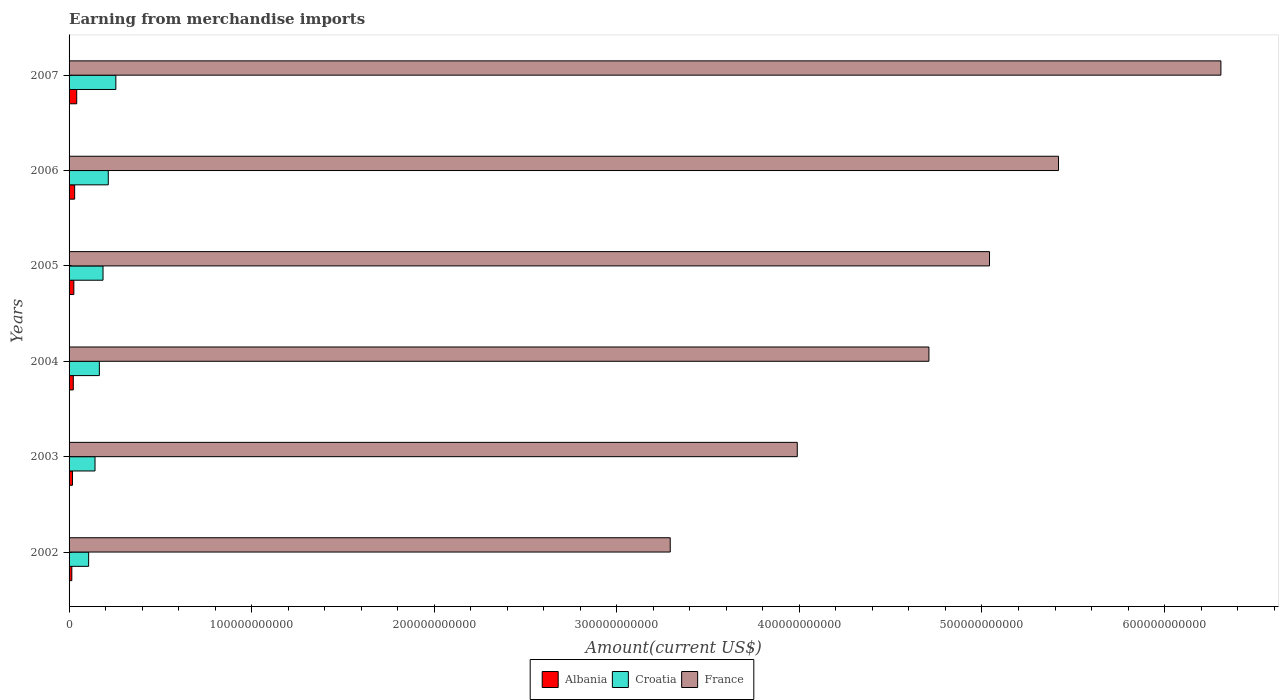How many different coloured bars are there?
Ensure brevity in your answer.  3. In how many cases, is the number of bars for a given year not equal to the number of legend labels?
Make the answer very short. 0. What is the amount earned from merchandise imports in Croatia in 2002?
Provide a short and direct response. 1.07e+1. Across all years, what is the maximum amount earned from merchandise imports in Albania?
Keep it short and to the point. 4.19e+09. Across all years, what is the minimum amount earned from merchandise imports in Croatia?
Offer a terse response. 1.07e+1. In which year was the amount earned from merchandise imports in Albania maximum?
Your response must be concise. 2007. In which year was the amount earned from merchandise imports in France minimum?
Provide a short and direct response. 2002. What is the total amount earned from merchandise imports in France in the graph?
Offer a very short reply. 2.88e+12. What is the difference between the amount earned from merchandise imports in France in 2004 and that in 2007?
Make the answer very short. -1.60e+11. What is the difference between the amount earned from merchandise imports in Croatia in 2007 and the amount earned from merchandise imports in Albania in 2003?
Make the answer very short. 2.38e+1. What is the average amount earned from merchandise imports in Albania per year?
Your answer should be compact. 2.59e+09. In the year 2005, what is the difference between the amount earned from merchandise imports in Croatia and amount earned from merchandise imports in Albania?
Keep it short and to the point. 1.60e+1. What is the ratio of the amount earned from merchandise imports in Albania in 2003 to that in 2004?
Your answer should be very brief. 0.81. Is the difference between the amount earned from merchandise imports in Croatia in 2003 and 2007 greater than the difference between the amount earned from merchandise imports in Albania in 2003 and 2007?
Your answer should be very brief. No. What is the difference between the highest and the second highest amount earned from merchandise imports in Croatia?
Your answer should be compact. 4.14e+09. What is the difference between the highest and the lowest amount earned from merchandise imports in France?
Give a very brief answer. 3.02e+11. In how many years, is the amount earned from merchandise imports in Albania greater than the average amount earned from merchandise imports in Albania taken over all years?
Provide a succinct answer. 3. Is the sum of the amount earned from merchandise imports in France in 2006 and 2007 greater than the maximum amount earned from merchandise imports in Croatia across all years?
Ensure brevity in your answer.  Yes. What does the 2nd bar from the top in 2006 represents?
Make the answer very short. Croatia. What does the 2nd bar from the bottom in 2007 represents?
Your answer should be compact. Croatia. Is it the case that in every year, the sum of the amount earned from merchandise imports in Albania and amount earned from merchandise imports in France is greater than the amount earned from merchandise imports in Croatia?
Keep it short and to the point. Yes. How many bars are there?
Offer a very short reply. 18. How many years are there in the graph?
Provide a short and direct response. 6. What is the difference between two consecutive major ticks on the X-axis?
Provide a succinct answer. 1.00e+11. Are the values on the major ticks of X-axis written in scientific E-notation?
Ensure brevity in your answer.  No. Does the graph contain grids?
Provide a short and direct response. No. Where does the legend appear in the graph?
Keep it short and to the point. Bottom center. How many legend labels are there?
Ensure brevity in your answer.  3. How are the legend labels stacked?
Provide a short and direct response. Horizontal. What is the title of the graph?
Make the answer very short. Earning from merchandise imports. What is the label or title of the X-axis?
Provide a short and direct response. Amount(current US$). What is the Amount(current US$) of Albania in 2002?
Ensure brevity in your answer.  1.50e+09. What is the Amount(current US$) of Croatia in 2002?
Give a very brief answer. 1.07e+1. What is the Amount(current US$) in France in 2002?
Make the answer very short. 3.29e+11. What is the Amount(current US$) of Albania in 2003?
Make the answer very short. 1.86e+09. What is the Amount(current US$) of Croatia in 2003?
Your answer should be very brief. 1.42e+1. What is the Amount(current US$) in France in 2003?
Provide a succinct answer. 3.99e+11. What is the Amount(current US$) in Albania in 2004?
Offer a very short reply. 2.31e+09. What is the Amount(current US$) of Croatia in 2004?
Your answer should be compact. 1.66e+1. What is the Amount(current US$) of France in 2004?
Keep it short and to the point. 4.71e+11. What is the Amount(current US$) of Albania in 2005?
Ensure brevity in your answer.  2.62e+09. What is the Amount(current US$) of Croatia in 2005?
Your response must be concise. 1.86e+1. What is the Amount(current US$) in France in 2005?
Offer a very short reply. 5.04e+11. What is the Amount(current US$) in Albania in 2006?
Offer a very short reply. 3.06e+09. What is the Amount(current US$) in Croatia in 2006?
Your response must be concise. 2.15e+1. What is the Amount(current US$) of France in 2006?
Ensure brevity in your answer.  5.42e+11. What is the Amount(current US$) in Albania in 2007?
Your answer should be very brief. 4.19e+09. What is the Amount(current US$) of Croatia in 2007?
Ensure brevity in your answer.  2.56e+1. What is the Amount(current US$) in France in 2007?
Your answer should be very brief. 6.31e+11. Across all years, what is the maximum Amount(current US$) in Albania?
Keep it short and to the point. 4.19e+09. Across all years, what is the maximum Amount(current US$) in Croatia?
Provide a succinct answer. 2.56e+1. Across all years, what is the maximum Amount(current US$) of France?
Your answer should be very brief. 6.31e+11. Across all years, what is the minimum Amount(current US$) in Albania?
Make the answer very short. 1.50e+09. Across all years, what is the minimum Amount(current US$) in Croatia?
Give a very brief answer. 1.07e+1. Across all years, what is the minimum Amount(current US$) of France?
Keep it short and to the point. 3.29e+11. What is the total Amount(current US$) of Albania in the graph?
Your answer should be compact. 1.55e+1. What is the total Amount(current US$) in Croatia in the graph?
Ensure brevity in your answer.  1.07e+11. What is the total Amount(current US$) in France in the graph?
Make the answer very short. 2.88e+12. What is the difference between the Amount(current US$) of Albania in 2002 and that in 2003?
Offer a terse response. -3.60e+08. What is the difference between the Amount(current US$) of Croatia in 2002 and that in 2003?
Your response must be concise. -3.49e+09. What is the difference between the Amount(current US$) in France in 2002 and that in 2003?
Provide a short and direct response. -6.96e+1. What is the difference between the Amount(current US$) in Albania in 2002 and that in 2004?
Make the answer very short. -8.05e+08. What is the difference between the Amount(current US$) in Croatia in 2002 and that in 2004?
Ensure brevity in your answer.  -5.87e+09. What is the difference between the Amount(current US$) of France in 2002 and that in 2004?
Your answer should be compact. -1.42e+11. What is the difference between the Amount(current US$) in Albania in 2002 and that in 2005?
Your answer should be compact. -1.11e+09. What is the difference between the Amount(current US$) in Croatia in 2002 and that in 2005?
Offer a terse response. -7.88e+09. What is the difference between the Amount(current US$) in France in 2002 and that in 2005?
Offer a terse response. -1.75e+11. What is the difference between the Amount(current US$) of Albania in 2002 and that in 2006?
Your response must be concise. -1.55e+09. What is the difference between the Amount(current US$) in Croatia in 2002 and that in 2006?
Ensure brevity in your answer.  -1.08e+1. What is the difference between the Amount(current US$) of France in 2002 and that in 2006?
Make the answer very short. -2.13e+11. What is the difference between the Amount(current US$) in Albania in 2002 and that in 2007?
Give a very brief answer. -2.68e+09. What is the difference between the Amount(current US$) of Croatia in 2002 and that in 2007?
Give a very brief answer. -1.49e+1. What is the difference between the Amount(current US$) of France in 2002 and that in 2007?
Offer a terse response. -3.02e+11. What is the difference between the Amount(current US$) in Albania in 2003 and that in 2004?
Ensure brevity in your answer.  -4.45e+08. What is the difference between the Amount(current US$) of Croatia in 2003 and that in 2004?
Keep it short and to the point. -2.38e+09. What is the difference between the Amount(current US$) in France in 2003 and that in 2004?
Offer a terse response. -7.21e+1. What is the difference between the Amount(current US$) in Albania in 2003 and that in 2005?
Your response must be concise. -7.54e+08. What is the difference between the Amount(current US$) in Croatia in 2003 and that in 2005?
Make the answer very short. -4.39e+09. What is the difference between the Amount(current US$) in France in 2003 and that in 2005?
Your answer should be very brief. -1.05e+11. What is the difference between the Amount(current US$) in Albania in 2003 and that in 2006?
Your answer should be very brief. -1.19e+09. What is the difference between the Amount(current US$) of Croatia in 2003 and that in 2006?
Make the answer very short. -7.27e+09. What is the difference between the Amount(current US$) of France in 2003 and that in 2006?
Offer a terse response. -1.43e+11. What is the difference between the Amount(current US$) of Albania in 2003 and that in 2007?
Keep it short and to the point. -2.32e+09. What is the difference between the Amount(current US$) in Croatia in 2003 and that in 2007?
Keep it short and to the point. -1.14e+1. What is the difference between the Amount(current US$) of France in 2003 and that in 2007?
Offer a terse response. -2.32e+11. What is the difference between the Amount(current US$) of Albania in 2004 and that in 2005?
Your answer should be very brief. -3.09e+08. What is the difference between the Amount(current US$) in Croatia in 2004 and that in 2005?
Ensure brevity in your answer.  -2.01e+09. What is the difference between the Amount(current US$) of France in 2004 and that in 2005?
Give a very brief answer. -3.32e+1. What is the difference between the Amount(current US$) in Albania in 2004 and that in 2006?
Provide a succinct answer. -7.49e+08. What is the difference between the Amount(current US$) of Croatia in 2004 and that in 2006?
Provide a succinct answer. -4.89e+09. What is the difference between the Amount(current US$) of France in 2004 and that in 2006?
Keep it short and to the point. -7.10e+1. What is the difference between the Amount(current US$) of Albania in 2004 and that in 2007?
Your answer should be compact. -1.88e+09. What is the difference between the Amount(current US$) in Croatia in 2004 and that in 2007?
Your answer should be very brief. -9.03e+09. What is the difference between the Amount(current US$) in France in 2004 and that in 2007?
Your answer should be compact. -1.60e+11. What is the difference between the Amount(current US$) of Albania in 2005 and that in 2006?
Your answer should be compact. -4.40e+08. What is the difference between the Amount(current US$) in Croatia in 2005 and that in 2006?
Your response must be concise. -2.88e+09. What is the difference between the Amount(current US$) of France in 2005 and that in 2006?
Your response must be concise. -3.78e+1. What is the difference between the Amount(current US$) of Albania in 2005 and that in 2007?
Offer a very short reply. -1.57e+09. What is the difference between the Amount(current US$) in Croatia in 2005 and that in 2007?
Offer a terse response. -7.02e+09. What is the difference between the Amount(current US$) of France in 2005 and that in 2007?
Your answer should be compact. -1.27e+11. What is the difference between the Amount(current US$) in Albania in 2006 and that in 2007?
Offer a very short reply. -1.13e+09. What is the difference between the Amount(current US$) in Croatia in 2006 and that in 2007?
Keep it short and to the point. -4.14e+09. What is the difference between the Amount(current US$) in France in 2006 and that in 2007?
Offer a very short reply. -8.89e+1. What is the difference between the Amount(current US$) of Albania in 2002 and the Amount(current US$) of Croatia in 2003?
Provide a succinct answer. -1.27e+1. What is the difference between the Amount(current US$) of Albania in 2002 and the Amount(current US$) of France in 2003?
Offer a very short reply. -3.97e+11. What is the difference between the Amount(current US$) in Croatia in 2002 and the Amount(current US$) in France in 2003?
Offer a terse response. -3.88e+11. What is the difference between the Amount(current US$) in Albania in 2002 and the Amount(current US$) in Croatia in 2004?
Provide a succinct answer. -1.51e+1. What is the difference between the Amount(current US$) of Albania in 2002 and the Amount(current US$) of France in 2004?
Give a very brief answer. -4.69e+11. What is the difference between the Amount(current US$) of Croatia in 2002 and the Amount(current US$) of France in 2004?
Ensure brevity in your answer.  -4.60e+11. What is the difference between the Amount(current US$) of Albania in 2002 and the Amount(current US$) of Croatia in 2005?
Offer a terse response. -1.71e+1. What is the difference between the Amount(current US$) in Albania in 2002 and the Amount(current US$) in France in 2005?
Keep it short and to the point. -5.03e+11. What is the difference between the Amount(current US$) in Croatia in 2002 and the Amount(current US$) in France in 2005?
Your answer should be compact. -4.93e+11. What is the difference between the Amount(current US$) of Albania in 2002 and the Amount(current US$) of Croatia in 2006?
Give a very brief answer. -2.00e+1. What is the difference between the Amount(current US$) in Albania in 2002 and the Amount(current US$) in France in 2006?
Provide a short and direct response. -5.40e+11. What is the difference between the Amount(current US$) of Croatia in 2002 and the Amount(current US$) of France in 2006?
Provide a succinct answer. -5.31e+11. What is the difference between the Amount(current US$) of Albania in 2002 and the Amount(current US$) of Croatia in 2007?
Your answer should be very brief. -2.41e+1. What is the difference between the Amount(current US$) in Albania in 2002 and the Amount(current US$) in France in 2007?
Offer a very short reply. -6.29e+11. What is the difference between the Amount(current US$) in Croatia in 2002 and the Amount(current US$) in France in 2007?
Provide a short and direct response. -6.20e+11. What is the difference between the Amount(current US$) in Albania in 2003 and the Amount(current US$) in Croatia in 2004?
Ensure brevity in your answer.  -1.47e+1. What is the difference between the Amount(current US$) in Albania in 2003 and the Amount(current US$) in France in 2004?
Ensure brevity in your answer.  -4.69e+11. What is the difference between the Amount(current US$) of Croatia in 2003 and the Amount(current US$) of France in 2004?
Provide a succinct answer. -4.57e+11. What is the difference between the Amount(current US$) in Albania in 2003 and the Amount(current US$) in Croatia in 2005?
Give a very brief answer. -1.67e+1. What is the difference between the Amount(current US$) of Albania in 2003 and the Amount(current US$) of France in 2005?
Your answer should be very brief. -5.02e+11. What is the difference between the Amount(current US$) in Croatia in 2003 and the Amount(current US$) in France in 2005?
Give a very brief answer. -4.90e+11. What is the difference between the Amount(current US$) of Albania in 2003 and the Amount(current US$) of Croatia in 2006?
Offer a terse response. -1.96e+1. What is the difference between the Amount(current US$) in Albania in 2003 and the Amount(current US$) in France in 2006?
Give a very brief answer. -5.40e+11. What is the difference between the Amount(current US$) in Croatia in 2003 and the Amount(current US$) in France in 2006?
Keep it short and to the point. -5.28e+11. What is the difference between the Amount(current US$) of Albania in 2003 and the Amount(current US$) of Croatia in 2007?
Provide a succinct answer. -2.38e+1. What is the difference between the Amount(current US$) of Albania in 2003 and the Amount(current US$) of France in 2007?
Your response must be concise. -6.29e+11. What is the difference between the Amount(current US$) of Croatia in 2003 and the Amount(current US$) of France in 2007?
Provide a short and direct response. -6.17e+11. What is the difference between the Amount(current US$) of Albania in 2004 and the Amount(current US$) of Croatia in 2005?
Make the answer very short. -1.63e+1. What is the difference between the Amount(current US$) of Albania in 2004 and the Amount(current US$) of France in 2005?
Ensure brevity in your answer.  -5.02e+11. What is the difference between the Amount(current US$) of Croatia in 2004 and the Amount(current US$) of France in 2005?
Your answer should be compact. -4.88e+11. What is the difference between the Amount(current US$) in Albania in 2004 and the Amount(current US$) in Croatia in 2006?
Your answer should be compact. -1.92e+1. What is the difference between the Amount(current US$) of Albania in 2004 and the Amount(current US$) of France in 2006?
Provide a short and direct response. -5.40e+11. What is the difference between the Amount(current US$) of Croatia in 2004 and the Amount(current US$) of France in 2006?
Your answer should be very brief. -5.25e+11. What is the difference between the Amount(current US$) in Albania in 2004 and the Amount(current US$) in Croatia in 2007?
Provide a short and direct response. -2.33e+1. What is the difference between the Amount(current US$) in Albania in 2004 and the Amount(current US$) in France in 2007?
Offer a terse response. -6.29e+11. What is the difference between the Amount(current US$) in Croatia in 2004 and the Amount(current US$) in France in 2007?
Offer a terse response. -6.14e+11. What is the difference between the Amount(current US$) in Albania in 2005 and the Amount(current US$) in Croatia in 2006?
Your response must be concise. -1.89e+1. What is the difference between the Amount(current US$) of Albania in 2005 and the Amount(current US$) of France in 2006?
Keep it short and to the point. -5.39e+11. What is the difference between the Amount(current US$) in Croatia in 2005 and the Amount(current US$) in France in 2006?
Offer a terse response. -5.23e+11. What is the difference between the Amount(current US$) of Albania in 2005 and the Amount(current US$) of Croatia in 2007?
Provide a short and direct response. -2.30e+1. What is the difference between the Amount(current US$) in Albania in 2005 and the Amount(current US$) in France in 2007?
Your answer should be very brief. -6.28e+11. What is the difference between the Amount(current US$) in Croatia in 2005 and the Amount(current US$) in France in 2007?
Offer a terse response. -6.12e+11. What is the difference between the Amount(current US$) of Albania in 2006 and the Amount(current US$) of Croatia in 2007?
Offer a very short reply. -2.26e+1. What is the difference between the Amount(current US$) in Albania in 2006 and the Amount(current US$) in France in 2007?
Make the answer very short. -6.28e+11. What is the difference between the Amount(current US$) in Croatia in 2006 and the Amount(current US$) in France in 2007?
Your response must be concise. -6.09e+11. What is the average Amount(current US$) of Albania per year?
Your answer should be compact. 2.59e+09. What is the average Amount(current US$) in Croatia per year?
Your response must be concise. 1.79e+1. What is the average Amount(current US$) in France per year?
Give a very brief answer. 4.79e+11. In the year 2002, what is the difference between the Amount(current US$) of Albania and Amount(current US$) of Croatia?
Offer a terse response. -9.22e+09. In the year 2002, what is the difference between the Amount(current US$) in Albania and Amount(current US$) in France?
Keep it short and to the point. -3.28e+11. In the year 2002, what is the difference between the Amount(current US$) of Croatia and Amount(current US$) of France?
Offer a very short reply. -3.19e+11. In the year 2003, what is the difference between the Amount(current US$) of Albania and Amount(current US$) of Croatia?
Your answer should be compact. -1.23e+1. In the year 2003, what is the difference between the Amount(current US$) of Albania and Amount(current US$) of France?
Your answer should be very brief. -3.97e+11. In the year 2003, what is the difference between the Amount(current US$) of Croatia and Amount(current US$) of France?
Offer a terse response. -3.85e+11. In the year 2004, what is the difference between the Amount(current US$) in Albania and Amount(current US$) in Croatia?
Provide a succinct answer. -1.43e+1. In the year 2004, what is the difference between the Amount(current US$) of Albania and Amount(current US$) of France?
Your answer should be very brief. -4.69e+11. In the year 2004, what is the difference between the Amount(current US$) in Croatia and Amount(current US$) in France?
Your answer should be very brief. -4.54e+11. In the year 2005, what is the difference between the Amount(current US$) of Albania and Amount(current US$) of Croatia?
Make the answer very short. -1.60e+1. In the year 2005, what is the difference between the Amount(current US$) of Albania and Amount(current US$) of France?
Your answer should be compact. -5.02e+11. In the year 2005, what is the difference between the Amount(current US$) in Croatia and Amount(current US$) in France?
Your answer should be very brief. -4.86e+11. In the year 2006, what is the difference between the Amount(current US$) in Albania and Amount(current US$) in Croatia?
Ensure brevity in your answer.  -1.84e+1. In the year 2006, what is the difference between the Amount(current US$) of Albania and Amount(current US$) of France?
Offer a terse response. -5.39e+11. In the year 2006, what is the difference between the Amount(current US$) in Croatia and Amount(current US$) in France?
Your answer should be compact. -5.20e+11. In the year 2007, what is the difference between the Amount(current US$) in Albania and Amount(current US$) in Croatia?
Keep it short and to the point. -2.14e+1. In the year 2007, what is the difference between the Amount(current US$) of Albania and Amount(current US$) of France?
Your answer should be compact. -6.27e+11. In the year 2007, what is the difference between the Amount(current US$) of Croatia and Amount(current US$) of France?
Your answer should be compact. -6.05e+11. What is the ratio of the Amount(current US$) of Albania in 2002 to that in 2003?
Your answer should be compact. 0.81. What is the ratio of the Amount(current US$) of Croatia in 2002 to that in 2003?
Offer a terse response. 0.75. What is the ratio of the Amount(current US$) in France in 2002 to that in 2003?
Give a very brief answer. 0.83. What is the ratio of the Amount(current US$) in Albania in 2002 to that in 2004?
Offer a very short reply. 0.65. What is the ratio of the Amount(current US$) in Croatia in 2002 to that in 2004?
Provide a short and direct response. 0.65. What is the ratio of the Amount(current US$) of France in 2002 to that in 2004?
Give a very brief answer. 0.7. What is the ratio of the Amount(current US$) in Albania in 2002 to that in 2005?
Your response must be concise. 0.57. What is the ratio of the Amount(current US$) in Croatia in 2002 to that in 2005?
Make the answer very short. 0.58. What is the ratio of the Amount(current US$) in France in 2002 to that in 2005?
Your answer should be compact. 0.65. What is the ratio of the Amount(current US$) in Albania in 2002 to that in 2006?
Provide a short and direct response. 0.49. What is the ratio of the Amount(current US$) in Croatia in 2002 to that in 2006?
Keep it short and to the point. 0.5. What is the ratio of the Amount(current US$) of France in 2002 to that in 2006?
Provide a succinct answer. 0.61. What is the ratio of the Amount(current US$) in Albania in 2002 to that in 2007?
Your answer should be compact. 0.36. What is the ratio of the Amount(current US$) in Croatia in 2002 to that in 2007?
Provide a succinct answer. 0.42. What is the ratio of the Amount(current US$) in France in 2002 to that in 2007?
Keep it short and to the point. 0.52. What is the ratio of the Amount(current US$) in Albania in 2003 to that in 2004?
Offer a very short reply. 0.81. What is the ratio of the Amount(current US$) of Croatia in 2003 to that in 2004?
Provide a short and direct response. 0.86. What is the ratio of the Amount(current US$) in France in 2003 to that in 2004?
Provide a short and direct response. 0.85. What is the ratio of the Amount(current US$) of Albania in 2003 to that in 2005?
Your answer should be compact. 0.71. What is the ratio of the Amount(current US$) of Croatia in 2003 to that in 2005?
Your answer should be compact. 0.76. What is the ratio of the Amount(current US$) in France in 2003 to that in 2005?
Provide a succinct answer. 0.79. What is the ratio of the Amount(current US$) of Albania in 2003 to that in 2006?
Offer a very short reply. 0.61. What is the ratio of the Amount(current US$) of Croatia in 2003 to that in 2006?
Your answer should be very brief. 0.66. What is the ratio of the Amount(current US$) in France in 2003 to that in 2006?
Give a very brief answer. 0.74. What is the ratio of the Amount(current US$) of Albania in 2003 to that in 2007?
Offer a terse response. 0.45. What is the ratio of the Amount(current US$) of Croatia in 2003 to that in 2007?
Your answer should be very brief. 0.55. What is the ratio of the Amount(current US$) of France in 2003 to that in 2007?
Provide a short and direct response. 0.63. What is the ratio of the Amount(current US$) of Albania in 2004 to that in 2005?
Ensure brevity in your answer.  0.88. What is the ratio of the Amount(current US$) of Croatia in 2004 to that in 2005?
Ensure brevity in your answer.  0.89. What is the ratio of the Amount(current US$) in France in 2004 to that in 2005?
Your answer should be very brief. 0.93. What is the ratio of the Amount(current US$) in Albania in 2004 to that in 2006?
Your answer should be very brief. 0.76. What is the ratio of the Amount(current US$) in Croatia in 2004 to that in 2006?
Offer a terse response. 0.77. What is the ratio of the Amount(current US$) in France in 2004 to that in 2006?
Give a very brief answer. 0.87. What is the ratio of the Amount(current US$) of Albania in 2004 to that in 2007?
Keep it short and to the point. 0.55. What is the ratio of the Amount(current US$) in Croatia in 2004 to that in 2007?
Offer a terse response. 0.65. What is the ratio of the Amount(current US$) of France in 2004 to that in 2007?
Provide a succinct answer. 0.75. What is the ratio of the Amount(current US$) of Albania in 2005 to that in 2006?
Ensure brevity in your answer.  0.86. What is the ratio of the Amount(current US$) in Croatia in 2005 to that in 2006?
Provide a short and direct response. 0.87. What is the ratio of the Amount(current US$) of France in 2005 to that in 2006?
Give a very brief answer. 0.93. What is the ratio of the Amount(current US$) of Albania in 2005 to that in 2007?
Your answer should be compact. 0.63. What is the ratio of the Amount(current US$) in Croatia in 2005 to that in 2007?
Your response must be concise. 0.73. What is the ratio of the Amount(current US$) in France in 2005 to that in 2007?
Make the answer very short. 0.8. What is the ratio of the Amount(current US$) of Albania in 2006 to that in 2007?
Provide a short and direct response. 0.73. What is the ratio of the Amount(current US$) of Croatia in 2006 to that in 2007?
Your answer should be compact. 0.84. What is the ratio of the Amount(current US$) in France in 2006 to that in 2007?
Offer a very short reply. 0.86. What is the difference between the highest and the second highest Amount(current US$) of Albania?
Your answer should be very brief. 1.13e+09. What is the difference between the highest and the second highest Amount(current US$) in Croatia?
Keep it short and to the point. 4.14e+09. What is the difference between the highest and the second highest Amount(current US$) in France?
Provide a succinct answer. 8.89e+1. What is the difference between the highest and the lowest Amount(current US$) of Albania?
Your answer should be compact. 2.68e+09. What is the difference between the highest and the lowest Amount(current US$) in Croatia?
Ensure brevity in your answer.  1.49e+1. What is the difference between the highest and the lowest Amount(current US$) in France?
Your answer should be compact. 3.02e+11. 